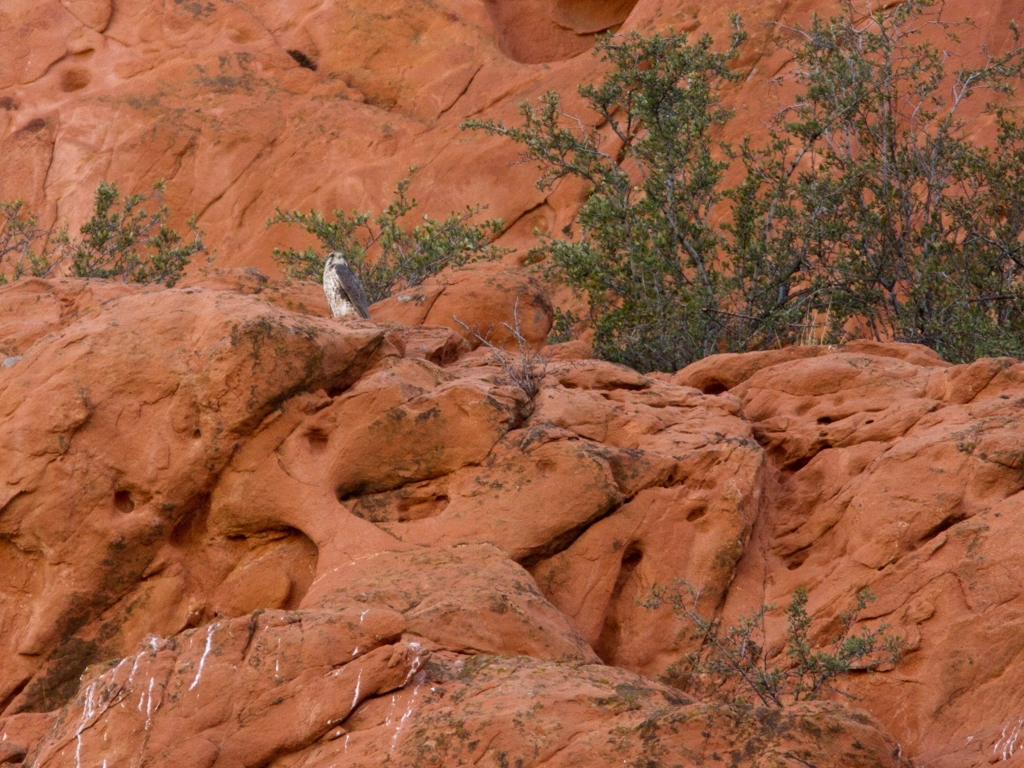How would you describe the lighting in the image?
A. artificial
B. natural
C. poor
D. good
Answer with the option's letter from the given choices directly. The lighting in the image appears to be option B, natural. This is suggested by the soft and diffuse quality of the light, which is indicative of an overcast day or the lighting conditions commonly found in outdoor settings. 